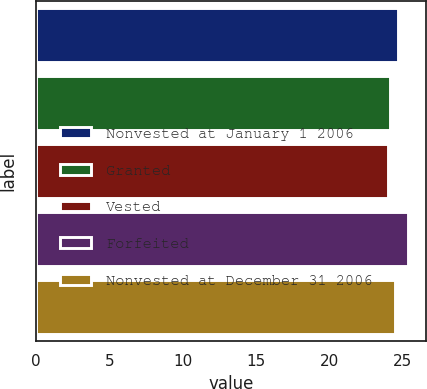Convert chart to OTSL. <chart><loc_0><loc_0><loc_500><loc_500><bar_chart><fcel>Nonvested at January 1 2006<fcel>Granted<fcel>Vested<fcel>Forfeited<fcel>Nonvested at December 31 2006<nl><fcel>24.67<fcel>24.13<fcel>23.99<fcel>25.36<fcel>24.51<nl></chart> 